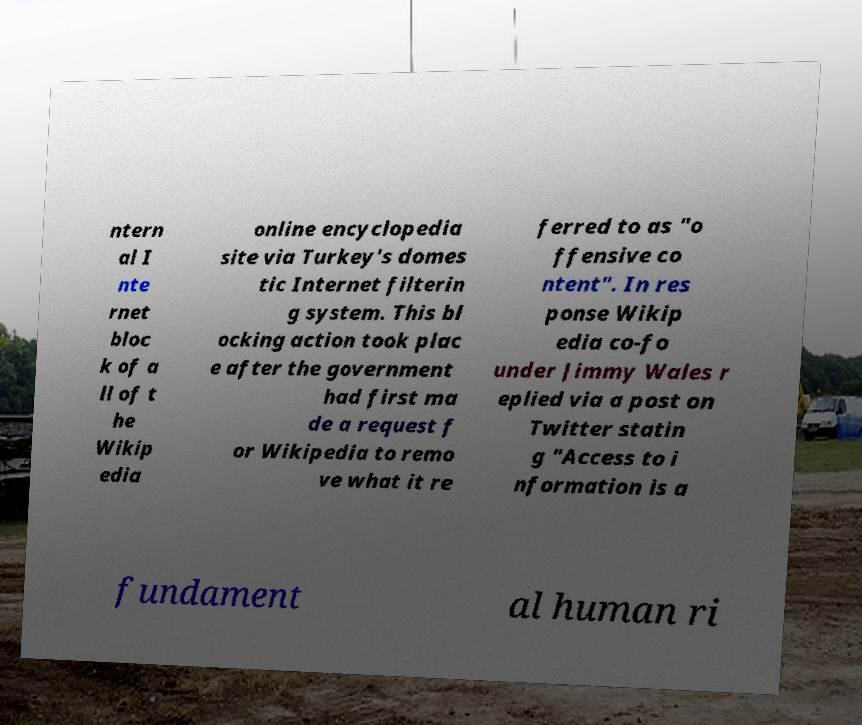Can you accurately transcribe the text from the provided image for me? ntern al I nte rnet bloc k of a ll of t he Wikip edia online encyclopedia site via Turkey's domes tic Internet filterin g system. This bl ocking action took plac e after the government had first ma de a request f or Wikipedia to remo ve what it re ferred to as "o ffensive co ntent". In res ponse Wikip edia co-fo under Jimmy Wales r eplied via a post on Twitter statin g "Access to i nformation is a fundament al human ri 